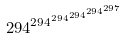<formula> <loc_0><loc_0><loc_500><loc_500>2 9 4 ^ { 2 9 4 ^ { 2 9 4 ^ { 2 9 4 ^ { 2 9 4 ^ { 2 9 7 } } } } }</formula> 